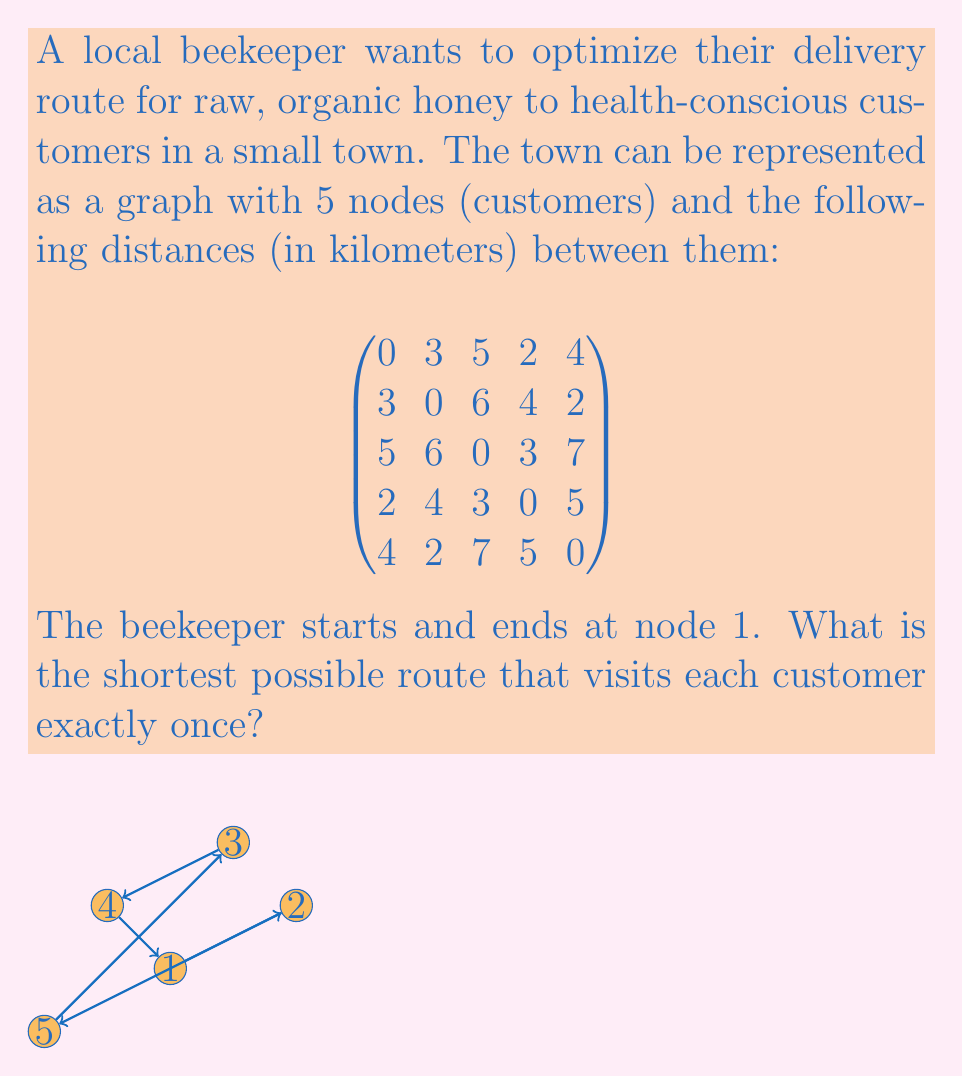Give your solution to this math problem. To solve this problem, we need to find the shortest Hamiltonian cycle in the given graph, which is known as the Traveling Salesman Problem (TSP). For a small graph with 5 nodes, we can use a brute-force approach to find the optimal solution.

Steps:
1. List all possible permutations of nodes 2, 3, 4, and 5 (since we start and end at node 1).
2. For each permutation, calculate the total distance of the route.
3. Choose the permutation with the shortest total distance.

Possible permutations:
1. 1-2-3-4-5-1
2. 1-2-3-5-4-1
3. 1-2-4-3-5-1
4. 1-2-4-5-3-1
5. 1-2-5-3-4-1
6. 1-2-5-4-3-1
7. 1-3-2-4-5-1
8. 1-3-2-5-4-1
9. 1-3-4-2-5-1
10. 1-3-4-5-2-1
11. 1-3-5-2-4-1
12. 1-3-5-4-2-1
13. 1-4-2-3-5-1
14. 1-4-2-5-3-1
15. 1-4-3-2-5-1
16. 1-4-3-5-2-1
17. 1-4-5-2-3-1
18. 1-4-5-3-2-1
19. 1-5-2-3-4-1
20. 1-5-2-4-3-1
21. 1-5-3-2-4-1
22. 1-5-3-4-2-1
23. 1-5-4-2-3-1
24. 1-5-4-3-2-1

Calculating the total distance for each permutation, we find that the shortest route is:

1-4-3-2-5-1

The total distance of this route is:

$2 + 3 + 6 + 2 + 4 = 17$ km

This route minimizes the total distance traveled while ensuring that each customer receives their raw, organic honey delivery.
Answer: The shortest possible route is 1-4-3-2-5-1, with a total distance of 17 km. 